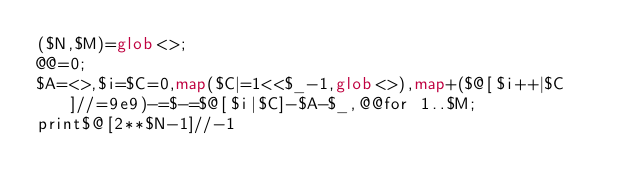Convert code to text. <code><loc_0><loc_0><loc_500><loc_500><_Perl_>($N,$M)=glob<>;
@@=0;
$A=<>,$i=$C=0,map($C|=1<<$_-1,glob<>),map+($@[$i++|$C]//=9e9)-=$-=$@[$i|$C]-$A-$_,@@for 1..$M;
print$@[2**$N-1]//-1</code> 